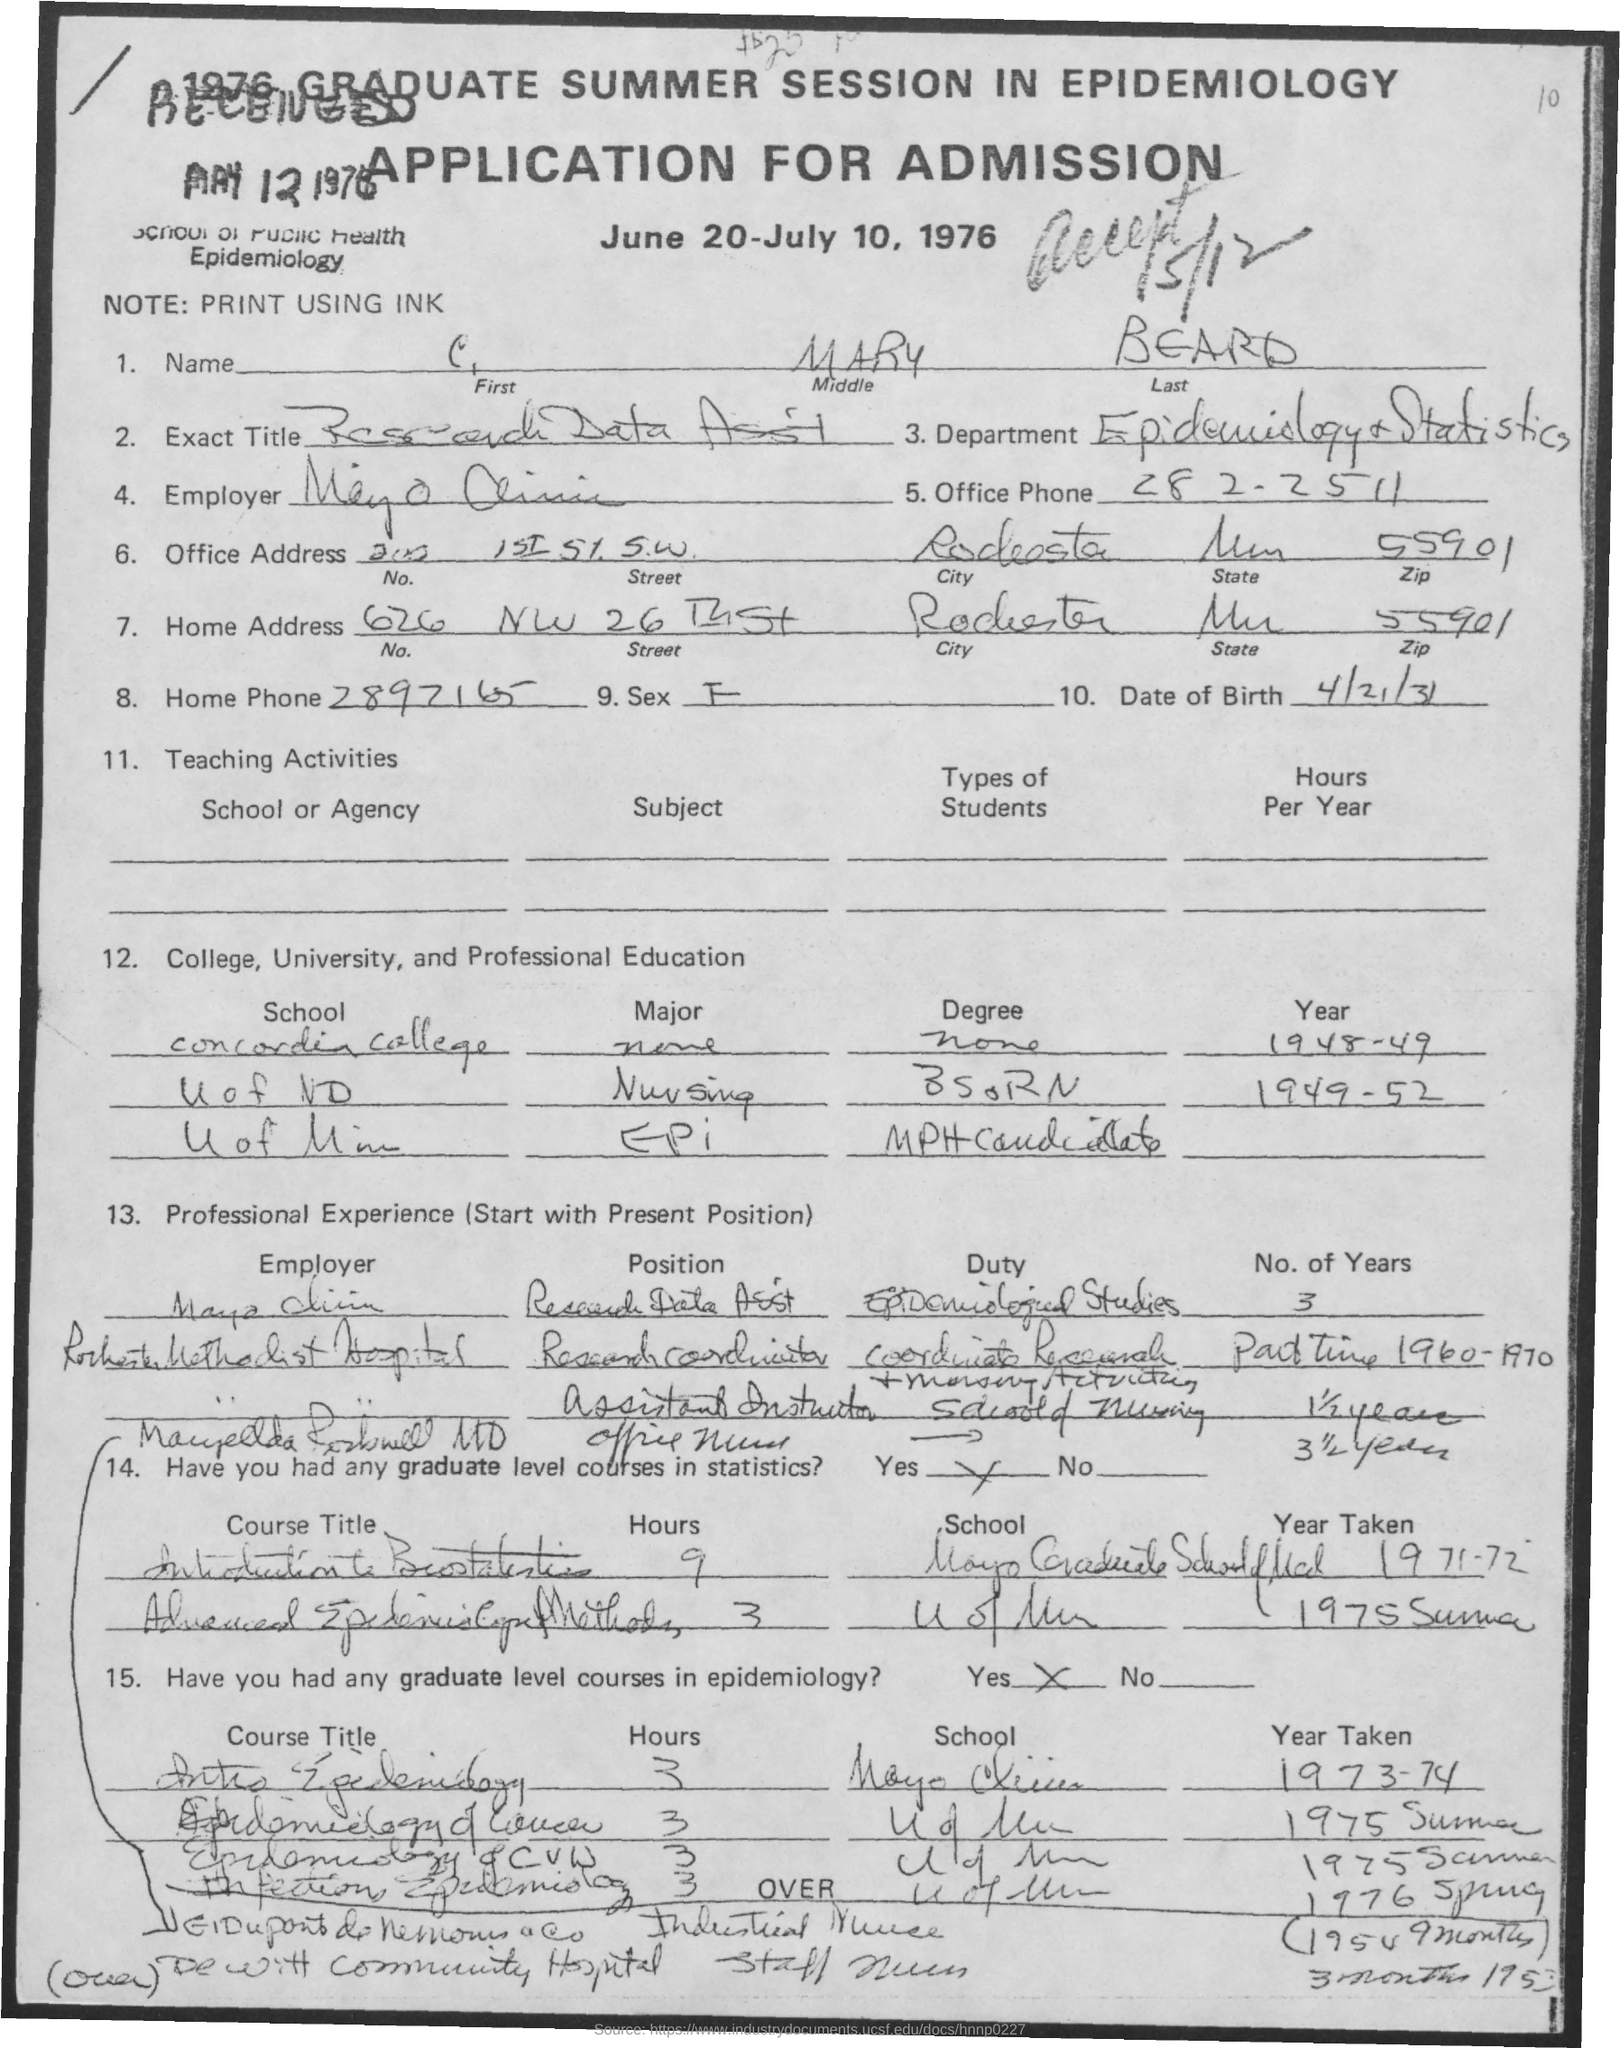Mention a couple of crucial points in this snapshot. The office phone number is 282-2511. The zip code for the address 55901 is... The name of the department is Epidemiology and Statistics. 